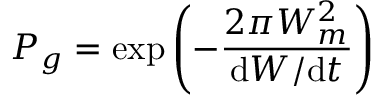<formula> <loc_0><loc_0><loc_500><loc_500>P _ { g } = \exp \left ( - { \frac { 2 \pi W _ { m } ^ { 2 } } { d W / d t } } \right )</formula> 